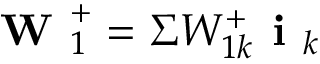Convert formula to latex. <formula><loc_0><loc_0><loc_500><loc_500>W _ { 1 } ^ { + } = \Sigma W _ { 1 k } ^ { + } i _ { k }</formula> 